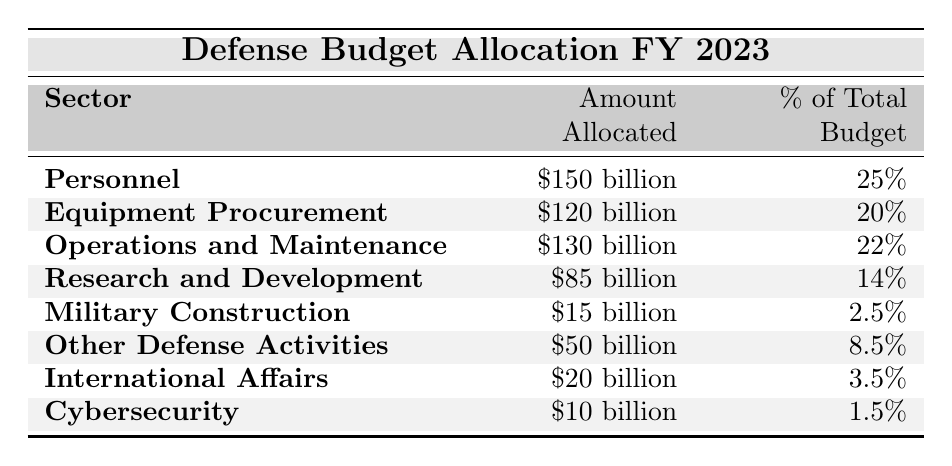What is the amount allocated for Personnel? According to the table, the amount allocated for Personnel is explicitly mentioned as 150 billion.
Answer: 150 billion Which sector has the highest percentage of the total budget? The table shows that Personnel has the highest percentage of the total budget at 25%, which is the maximum value in that column.
Answer: Personnel What is the total budget allocated for Operations and Maintenance and Equipment Procurement combined? To find the total for Operations and Maintenance and Equipment Procurement, add their allocated amounts: 130 billion + 120 billion = 250 billion.
Answer: 250 billion Is the amount allocated for Cybersecurity less than that for Military Construction? The table lists Cybersecurity's allocation as 10 billion and Military Construction's allocation as 15 billion. Since 10 billion is less than 15 billion, the statement is true.
Answer: Yes What percentage of the total budget is allocated to Research and Development compared to Military Construction? Research and Development is allocated 14% and Military Construction is allocated 2.5%. Comparing these, 14% is greater than 2.5%.
Answer: Research and Development is greater What is the combined budget allocation for Other Defense Activities and International Affairs? By adding the amounts, Other Defense Activities is 50 billion and International Affairs is 20 billion. So, 50 billion + 20 billion = 70 billion.
Answer: 70 billion What is the total budget allocated across all sectors? To find the total budget, add all the allocated amounts together: 150 billion + 120 billion + 130 billion + 85 billion + 15 billion + 50 billion + 20 billion + 10 billion = 630 billion.
Answer: 630 billion Does the amount for Equipment Procurement exceed that of Personnel? Equipment Procurement is allocated 120 billion while Personnel has 150 billion. Since 120 billion is less than 150 billion, Equipment Procurement does not exceed Personnel.
Answer: No What is the difference in percentage between the highest and the lowest sector allocations? The highest allocation is for Personnel at 25%, and the lowest is for Cybersecurity at 1.5%. The difference is 25% - 1.5% = 23.5%.
Answer: 23.5% If we combine the amounts for Research and Development, Military Construction, and Cybersecurity, what will be the total? The total is calculated by adding their amounts: 85 billion (Research and Development) + 15 billion (Military Construction) + 10 billion (Cybersecurity) = 110 billion.
Answer: 110 billion 